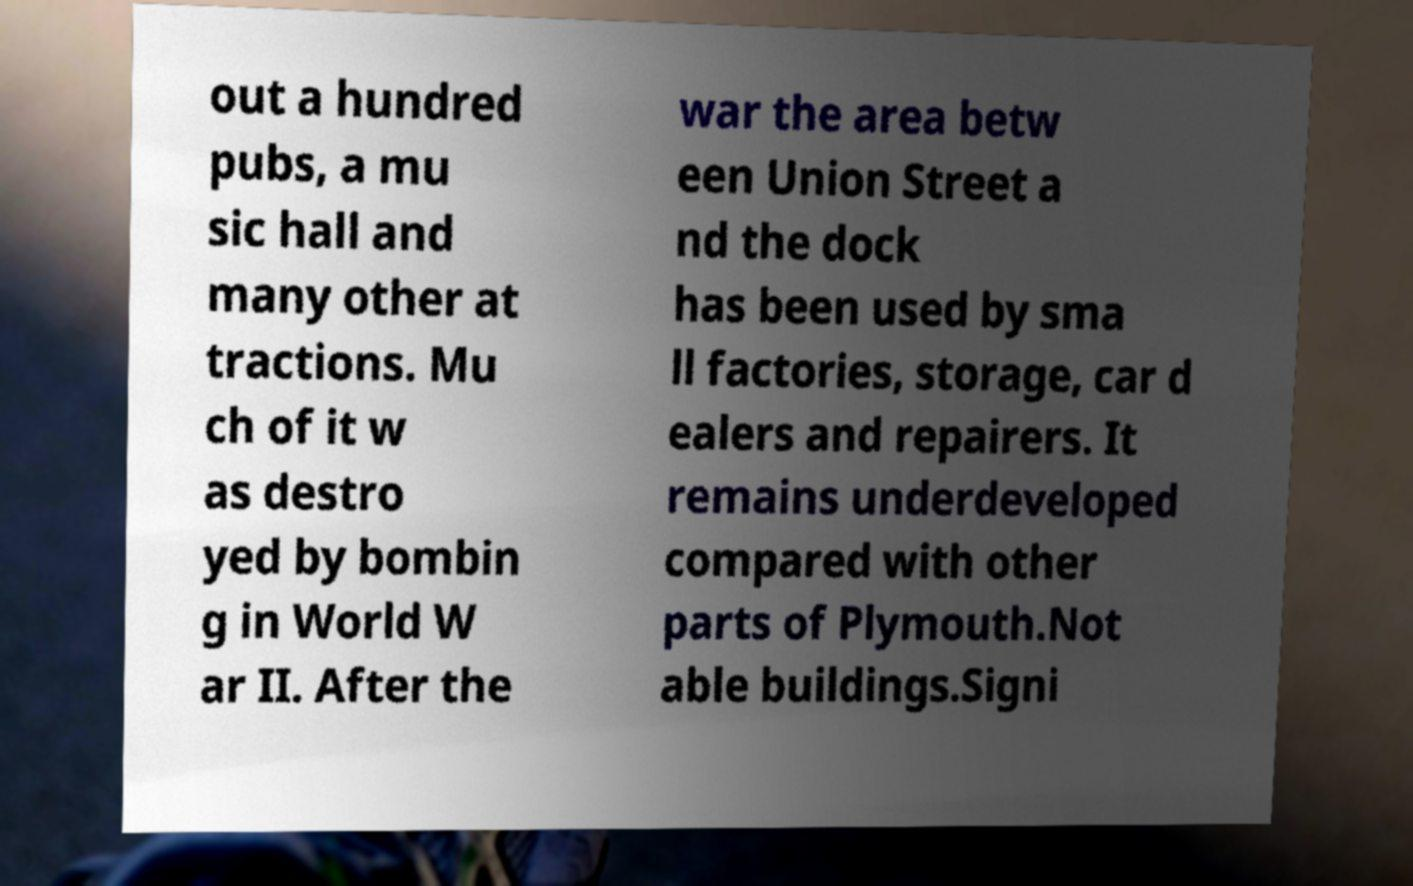Please read and relay the text visible in this image. What does it say? out a hundred pubs, a mu sic hall and many other at tractions. Mu ch of it w as destro yed by bombin g in World W ar II. After the war the area betw een Union Street a nd the dock has been used by sma ll factories, storage, car d ealers and repairers. It remains underdeveloped compared with other parts of Plymouth.Not able buildings.Signi 